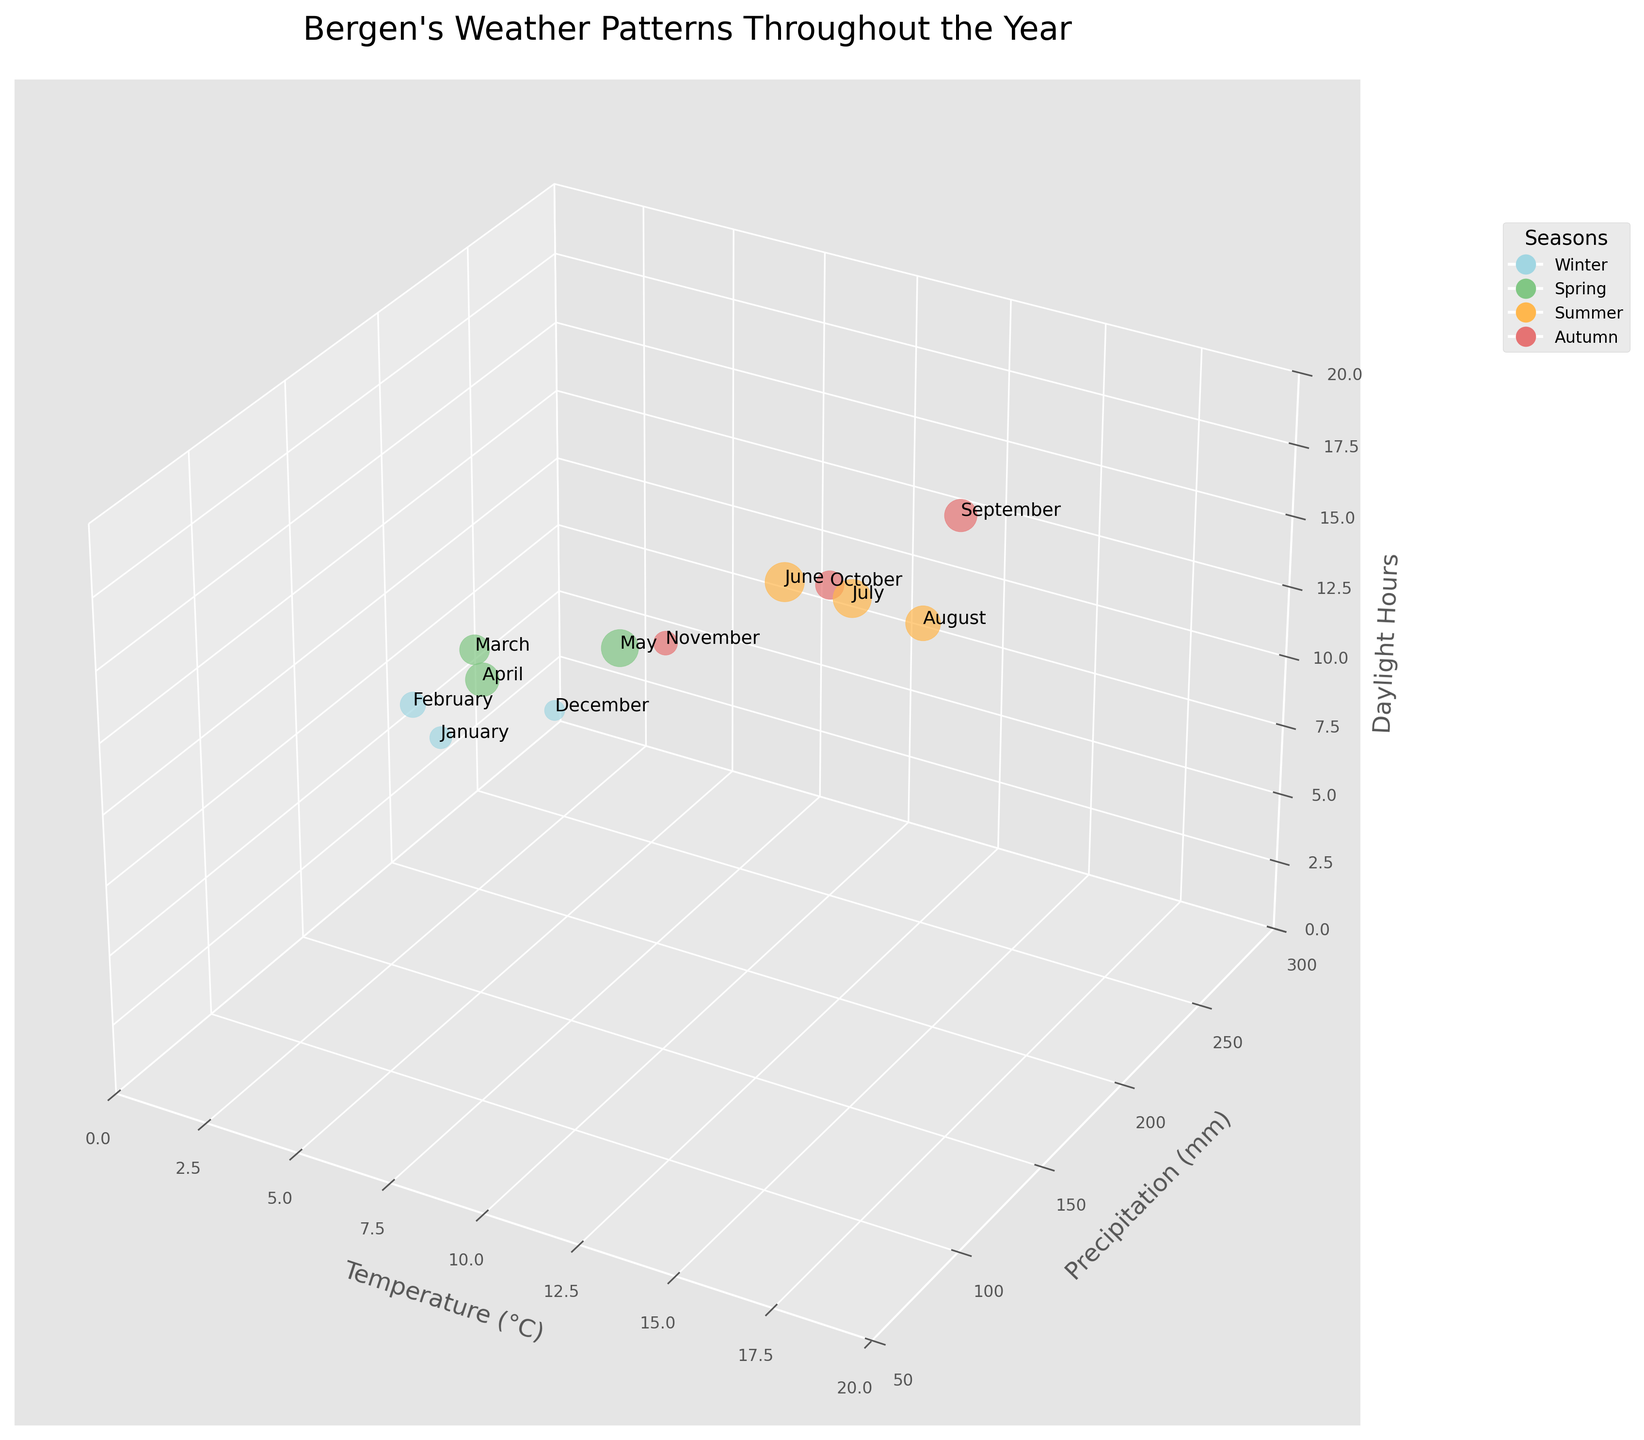How many data points are displayed in the figure? You can count the number of bubbles present in the 3D bubble chart. Each bubble represents one month. Since there are 12 months, there should be 12 bubbles in total.
Answer: 12 What season shows the highest precipitation? Identify the colored bubbles representing different seasons and compare their positions along the precipitation axis (Y-axis). Autumn has the highest precipitation, with September and October having the highest values.
Answer: Autumn In which month does Bergen experience the least daylight hours? Locate the bubbles along the Z-axis (Daylight Hours) and find the one with the lowest value. January and December both have the least daylight hours at 5 and 6 hours, respectively.
Answer: December Compare the temperature and precipitation in July and November. Which month is wetter? Look at the bubble for July and note its position on the Y-axis (Precipitation). Then, do the same for November. July has 148 mm of precipitation, while November has 259 mm. Thus, November is wetter.
Answer: November How does summer's temperature range compare to winter's? Identify the bubbles for the summer (June, July, August) and winter (January, February, December) seasons and note their temperatures. Summer temperatures range from 14°C-15°C, while winter temperatures range from 2°C-3°C. Summer has a higher temperature range.
Answer: Summer What's the average daylight hour in spring? Find the bubbles corresponding to the months in spring (March, April, May) and average their daylight hours. The values are 11, 14, and 17 hours respectively. (11 + 14 + 17) / 3 = 14 hours.
Answer: 14 hours Which month has the highest temperature and how many daylight hours does it have? Identify the bubble with the highest position on the X-axis (Temperature). July and August both have the highest temperature at 15°C. Check its position on the Z-axis for daylight hours. Both have 18 and 15 hours, respectively.
Answer: July with 18 hours What is the overall trend of precipitation as the temperature increases? Observe the general distribution of bubbles along the X-axis (Temperature) and see how the Y-axis (Precipitation) values change. Generally, precipitation values tend to vary, but there is no consistent increase or decrease as temperature increases.
Answer: No consistent trend In which season is there the least variation in daylight hours? Compare the range of daylight hours for the bubbles belonging to each season. Winter ranges from 5 to 8 hours (3 hours variation). Spring ranges from 11 to 17 hours (6 hours variation). Summer ranges from 15 to 19 hours (4 hours variation). Autumn ranges from 7 to 13 hours (6 hours variation). The least variation in daylight hours is in Winter.
Answer: Winter 